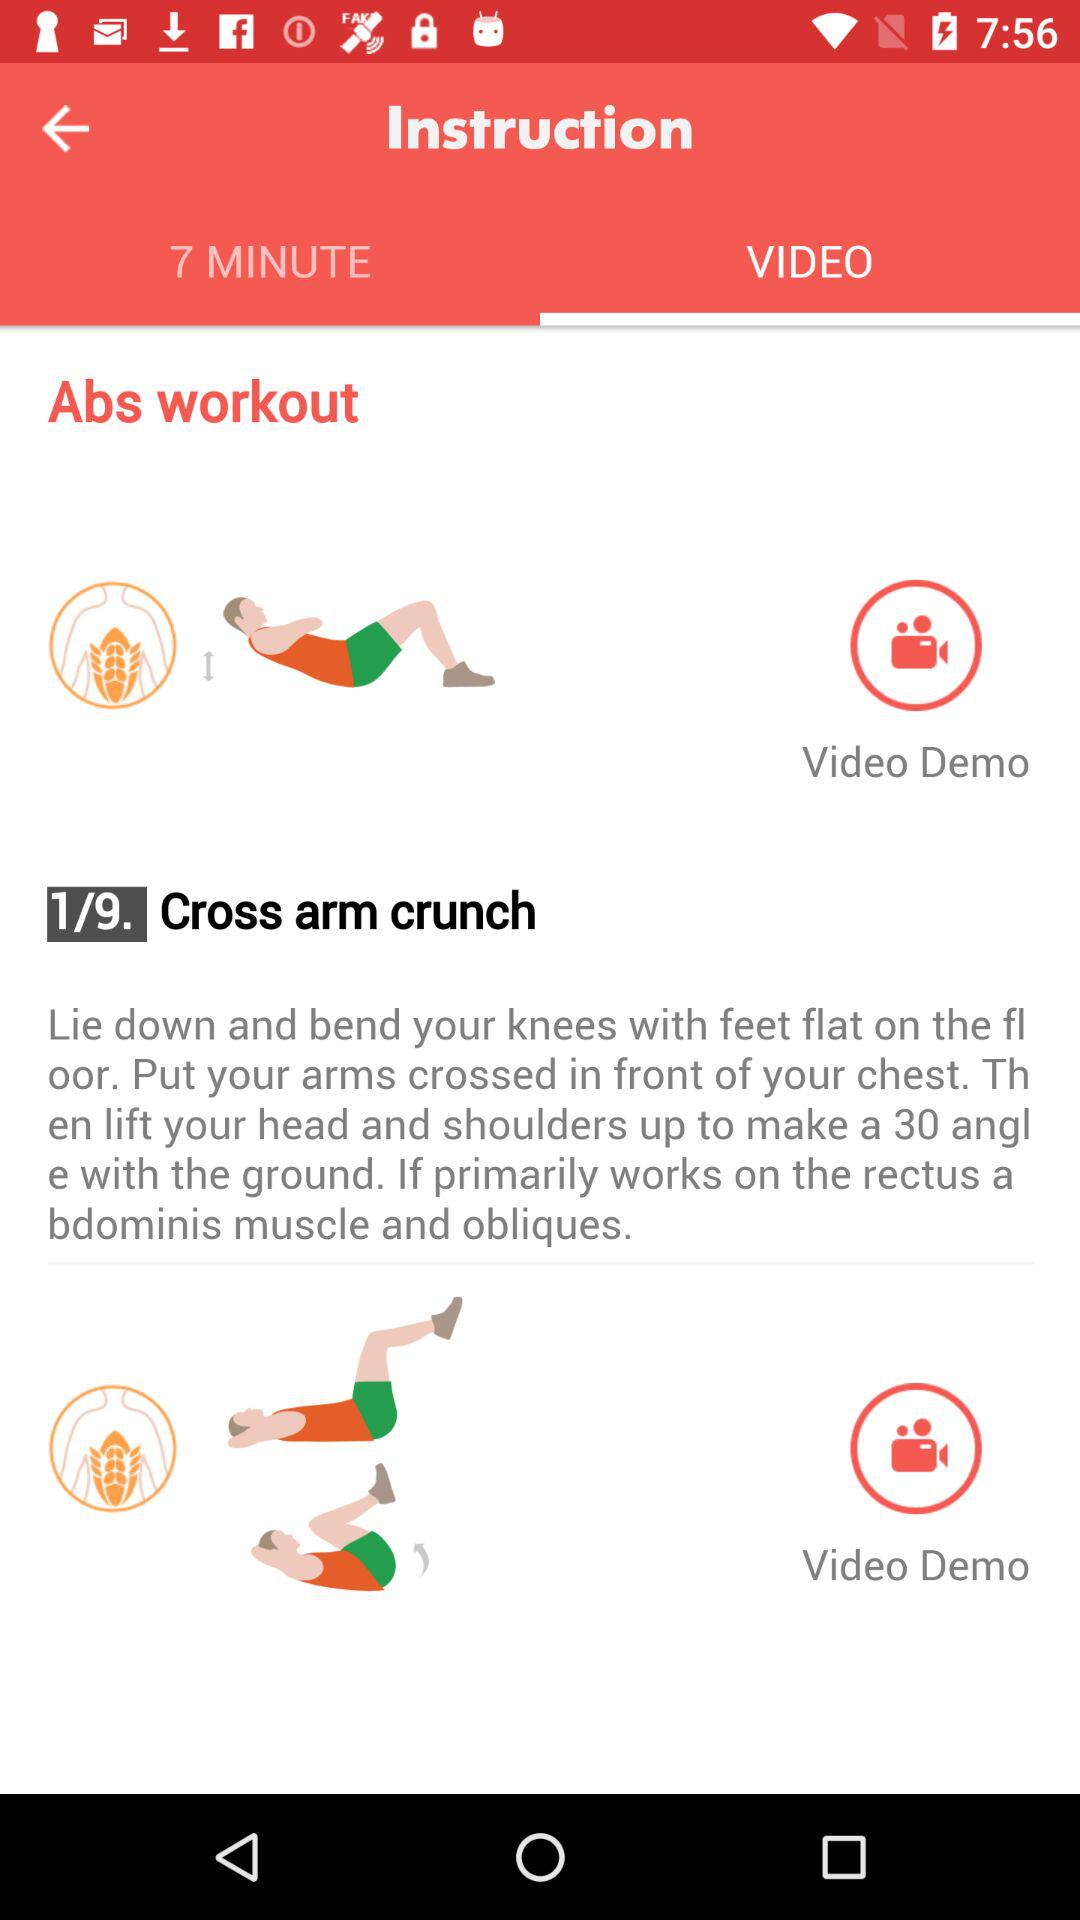What is the time duration?
When the provided information is insufficient, respond with <no answer>. <no answer> 